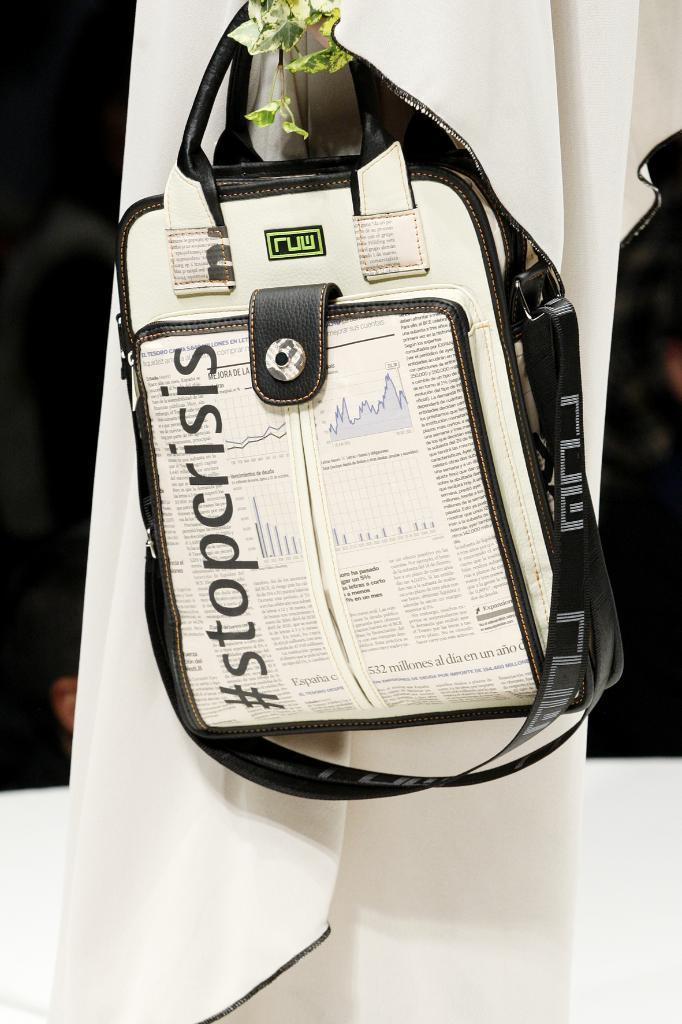What object is present in the image that can be used for carrying items? There is a bag in the image that can be used for carrying items. What color is the bag in the image? The bag is cream-colored. What message is written on the bag in the image? The bag is labeled "stop crisis." What can be seen in the background of the image? There is a white-colored cloth and leaves in the background of the image. How many cows are grazing in the background of the image? There are no cows present in the image; it only features a bag, a white-colored cloth, and leaves in the background. 